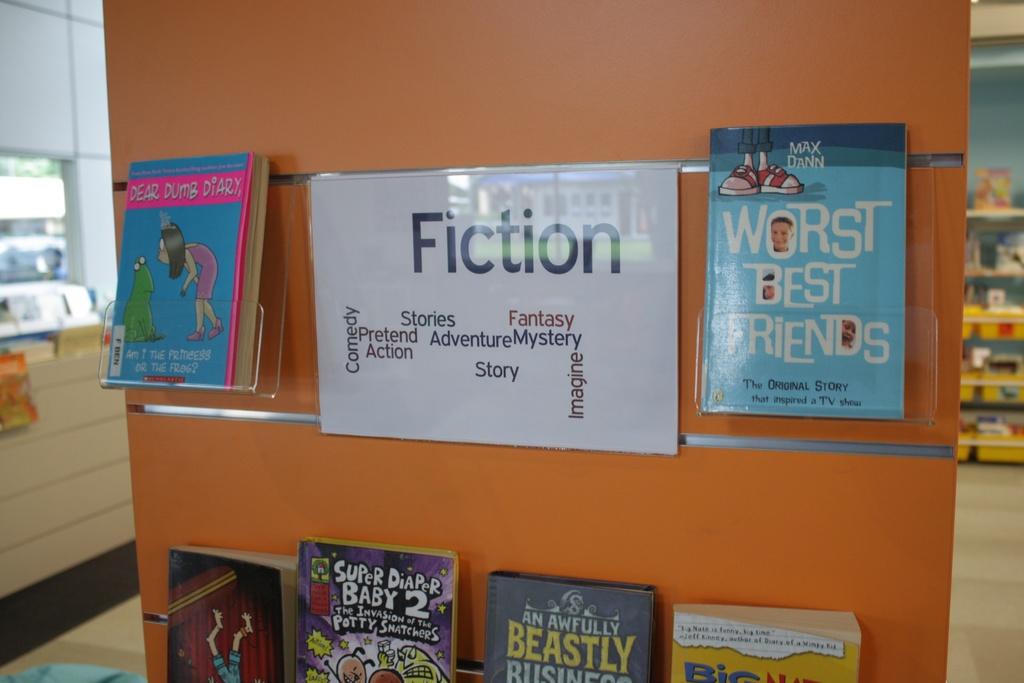What type of storeis this?
Keep it short and to the point. Fiction. What´s the name of the third book on the bottom?
Make the answer very short. An awfully beastly business. 